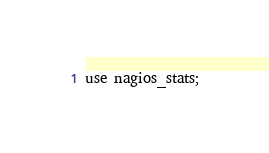Convert code to text. <code><loc_0><loc_0><loc_500><loc_500><_SQL_>use nagios_stats;</code> 